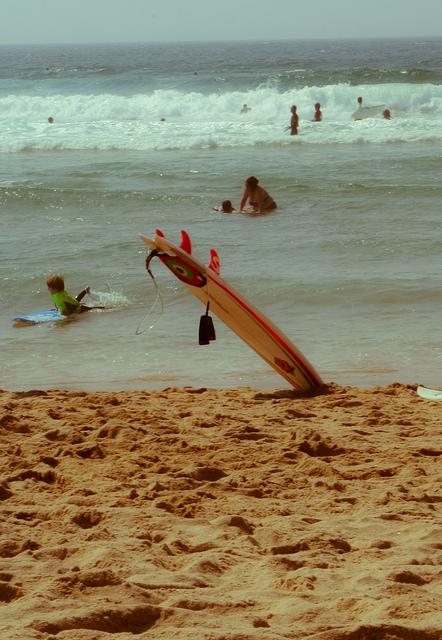Is it a nice day at the beach?
Write a very short answer. Yes. What's sticking out of the sand?
Write a very short answer. Surfboard. Is the water salty?
Answer briefly. Yes. 